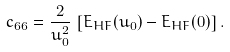<formula> <loc_0><loc_0><loc_500><loc_500>c _ { 6 6 } = \frac { 2 } { u _ { 0 } ^ { 2 } } \, \left [ E _ { H F } ( u _ { 0 } ) - E _ { H F } ( 0 ) \right ] .</formula> 